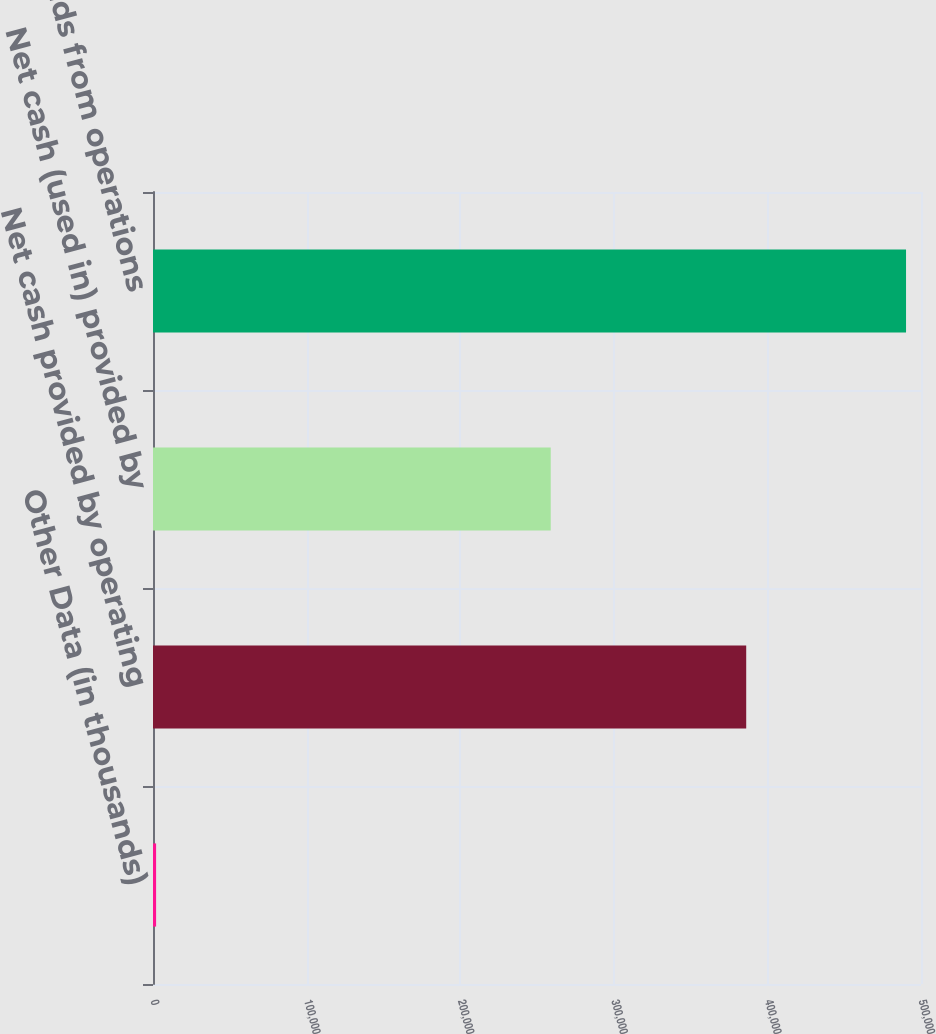Convert chart to OTSL. <chart><loc_0><loc_0><loc_500><loc_500><bar_chart><fcel>Other Data (in thousands)<fcel>Net cash provided by operating<fcel>Net cash (used in) provided by<fcel>Funds from operations<nl><fcel>2013<fcel>386203<fcel>258940<fcel>490255<nl></chart> 